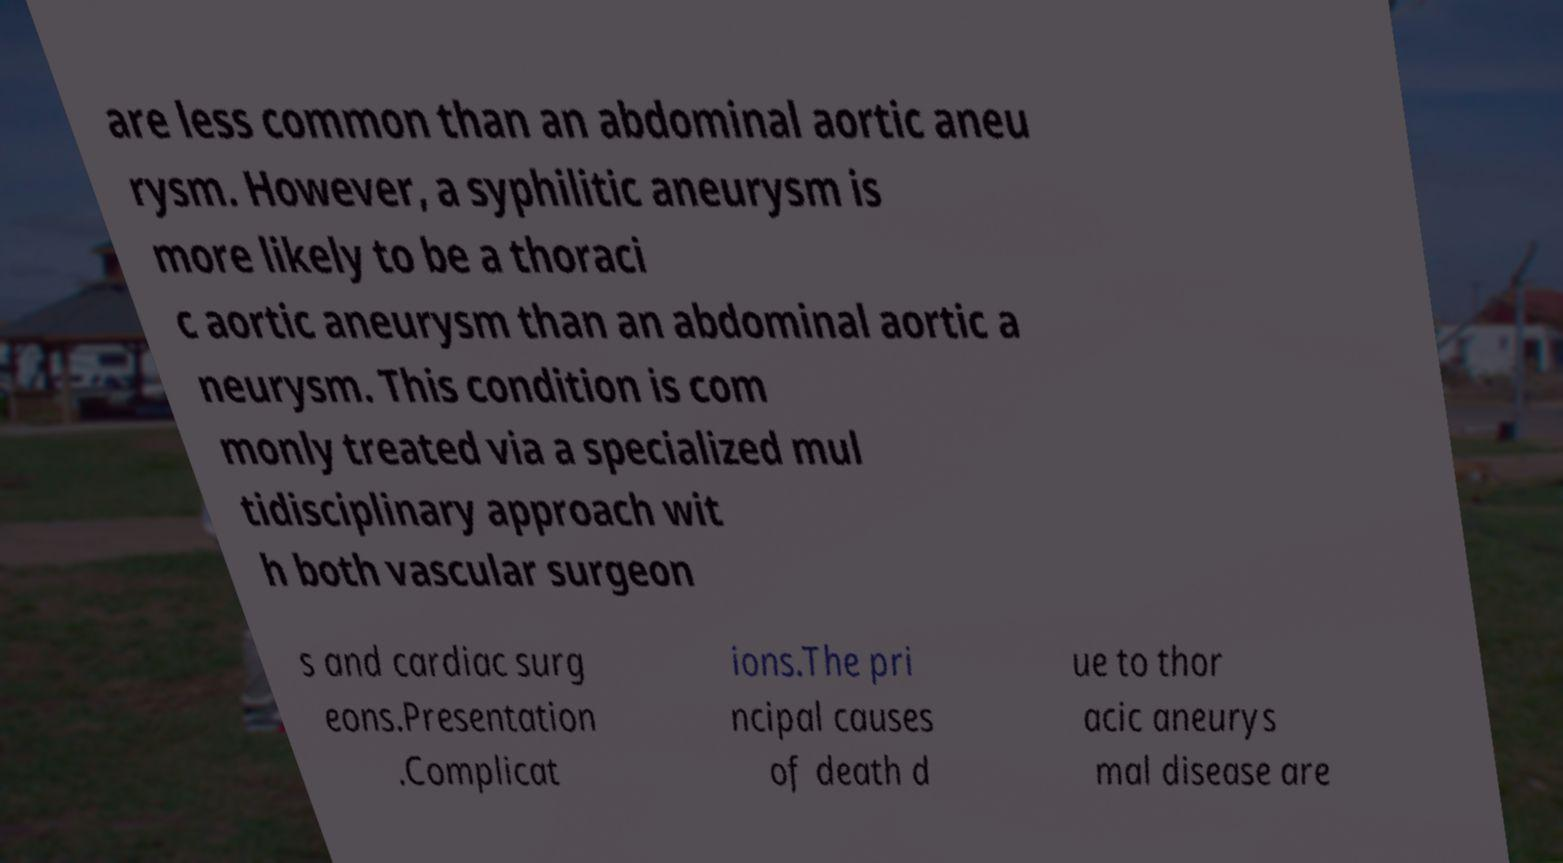For documentation purposes, I need the text within this image transcribed. Could you provide that? are less common than an abdominal aortic aneu rysm. However, a syphilitic aneurysm is more likely to be a thoraci c aortic aneurysm than an abdominal aortic a neurysm. This condition is com monly treated via a specialized mul tidisciplinary approach wit h both vascular surgeon s and cardiac surg eons.Presentation .Complicat ions.The pri ncipal causes of death d ue to thor acic aneurys mal disease are 